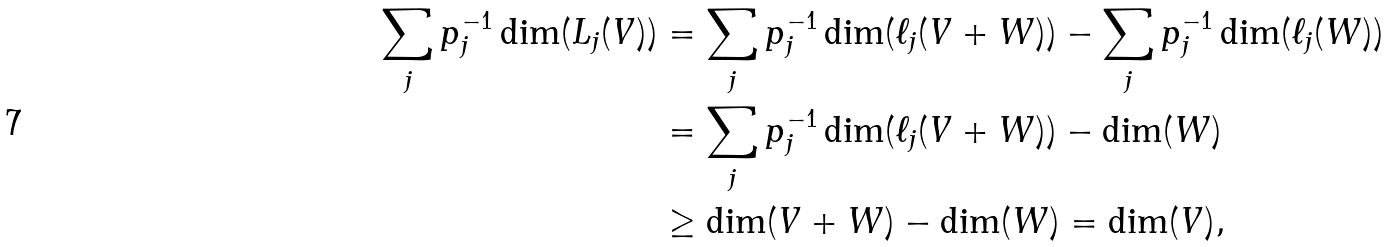<formula> <loc_0><loc_0><loc_500><loc_500>\sum _ { j } p _ { j } ^ { - 1 } \dim ( L _ { j } ( V ) ) & = \sum _ { j } p _ { j } ^ { - 1 } \dim ( \ell _ { j } ( V + W ) ) - \sum _ { j } p _ { j } ^ { - 1 } \dim ( \ell _ { j } ( W ) ) \\ & = \sum _ { j } p _ { j } ^ { - 1 } \dim ( \ell _ { j } ( V + W ) ) - \dim ( W ) \\ & \geq \dim ( V + W ) - \dim ( W ) = \dim ( V ) ,</formula> 